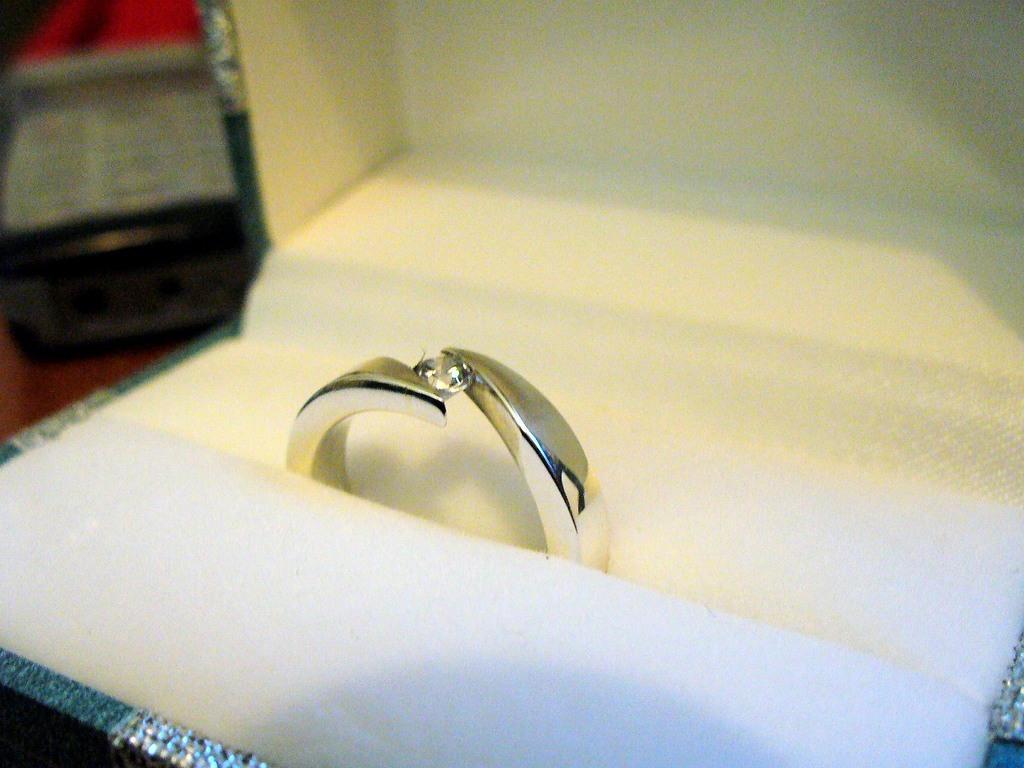Can you describe this image briefly? In the middle of the image we can see a ring and we can see blurry background. 